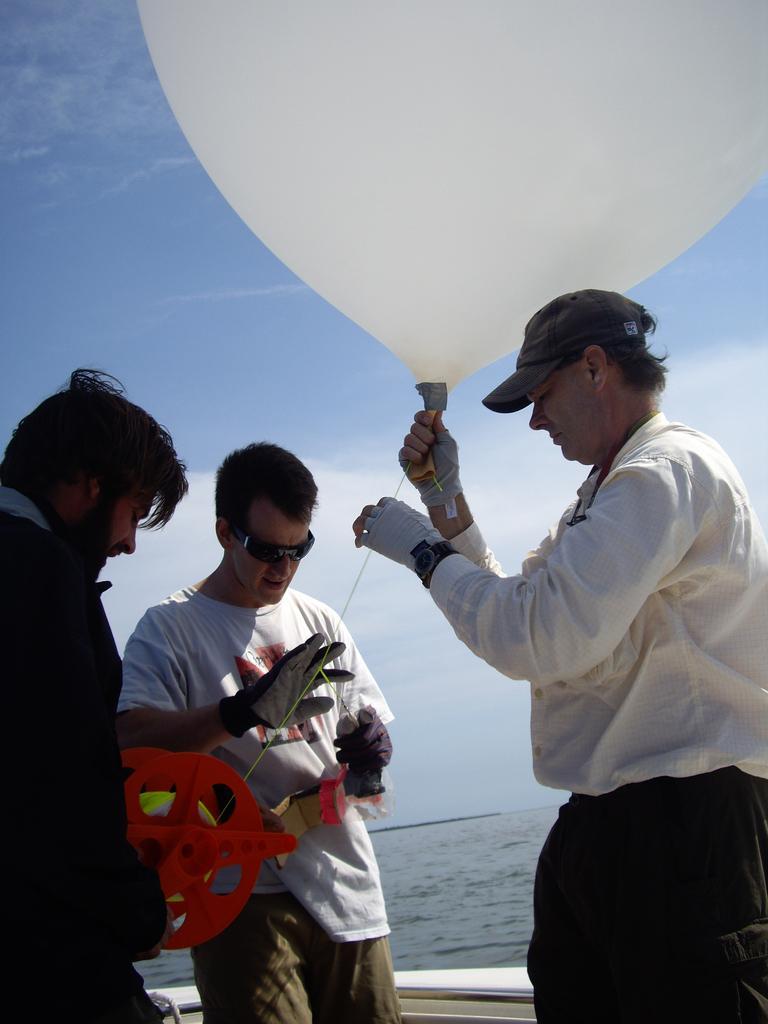Could you give a brief overview of what you see in this image? In this image, we can see people in the boat and some are wearing gloves and one of them is wearing a cap and all of them are holding a balloon and some other objects. In the background, there are clouds in the sky and there is water. 